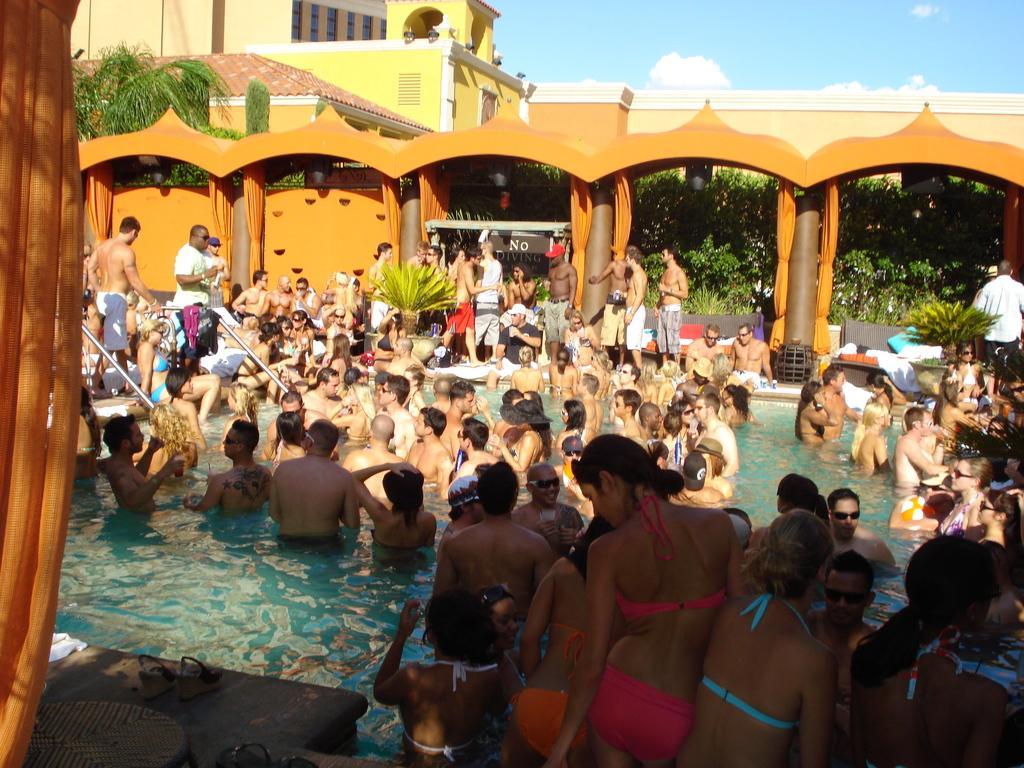Describe this image in one or two sentences. In this picture we can see a crowd of people some are in swimming pool and some are outside that and they are standing and the background we can see some building with windows, trees, sky with clouds, pillars, curtains and here is the table. 